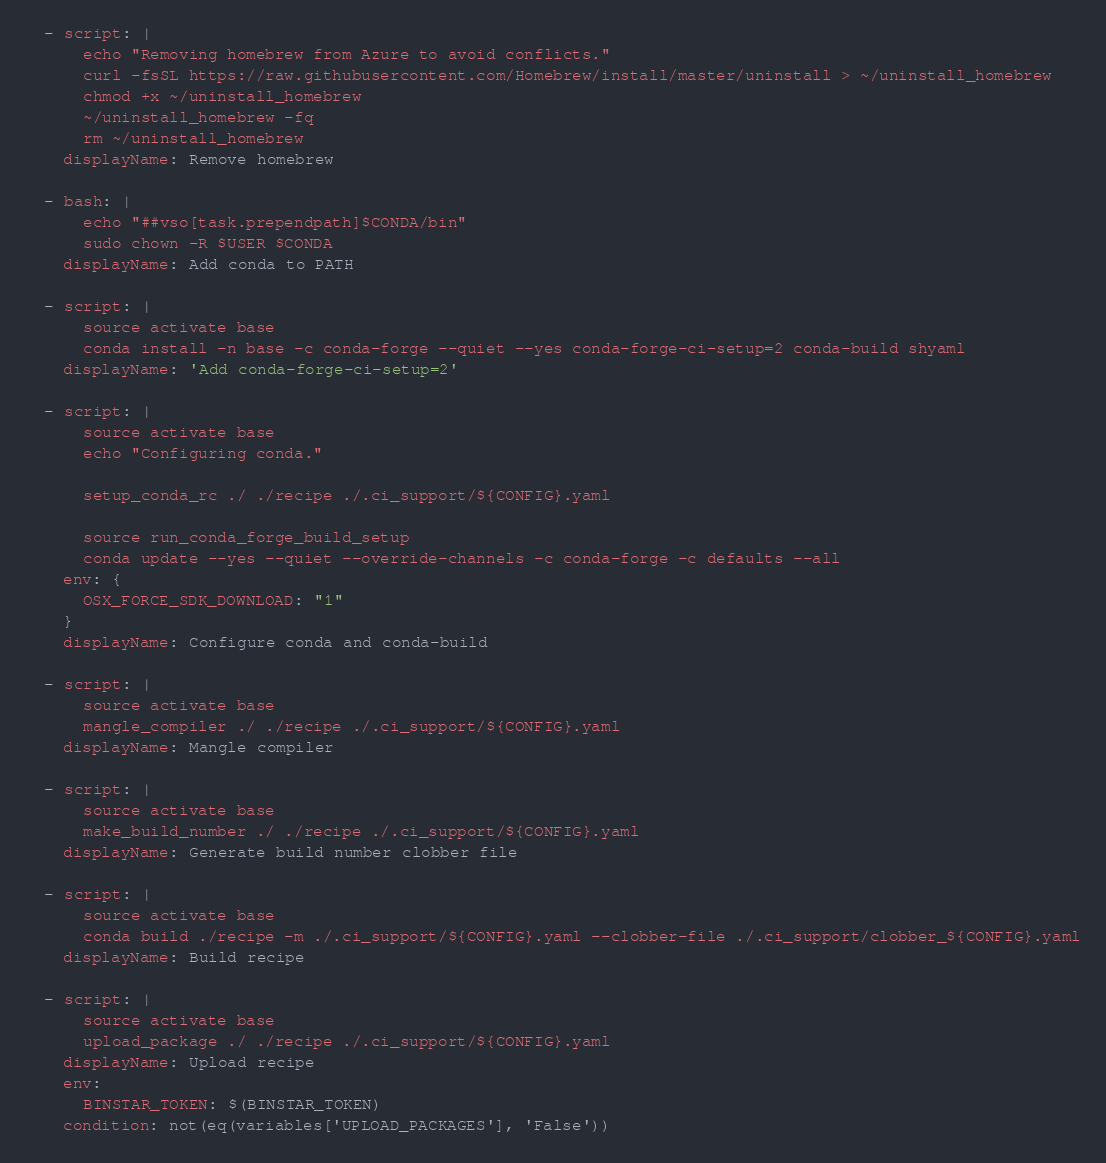Convert code to text. <code><loc_0><loc_0><loc_500><loc_500><_YAML_>
  - script: |
      echo "Removing homebrew from Azure to avoid conflicts."
      curl -fsSL https://raw.githubusercontent.com/Homebrew/install/master/uninstall > ~/uninstall_homebrew
      chmod +x ~/uninstall_homebrew
      ~/uninstall_homebrew -fq
      rm ~/uninstall_homebrew
    displayName: Remove homebrew

  - bash: |
      echo "##vso[task.prependpath]$CONDA/bin"
      sudo chown -R $USER $CONDA
    displayName: Add conda to PATH

  - script: |
      source activate base
      conda install -n base -c conda-forge --quiet --yes conda-forge-ci-setup=2 conda-build shyaml
    displayName: 'Add conda-forge-ci-setup=2'

  - script: |
      source activate base
      echo "Configuring conda."

      setup_conda_rc ./ ./recipe ./.ci_support/${CONFIG}.yaml

      source run_conda_forge_build_setup
      conda update --yes --quiet --override-channels -c conda-forge -c defaults --all
    env: {
      OSX_FORCE_SDK_DOWNLOAD: "1"
    }
    displayName: Configure conda and conda-build

  - script: |
      source activate base
      mangle_compiler ./ ./recipe ./.ci_support/${CONFIG}.yaml
    displayName: Mangle compiler

  - script: |
      source activate base
      make_build_number ./ ./recipe ./.ci_support/${CONFIG}.yaml
    displayName: Generate build number clobber file

  - script: |
      source activate base
      conda build ./recipe -m ./.ci_support/${CONFIG}.yaml --clobber-file ./.ci_support/clobber_${CONFIG}.yaml
    displayName: Build recipe

  - script: |
      source activate base
      upload_package ./ ./recipe ./.ci_support/${CONFIG}.yaml
    displayName: Upload recipe
    env:
      BINSTAR_TOKEN: $(BINSTAR_TOKEN)
    condition: not(eq(variables['UPLOAD_PACKAGES'], 'False'))</code> 